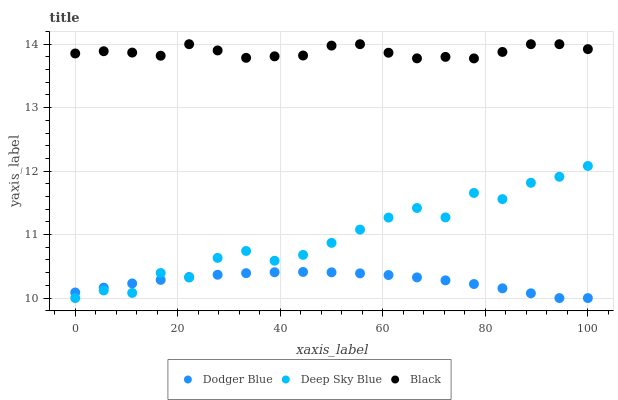Does Dodger Blue have the minimum area under the curve?
Answer yes or no. Yes. Does Black have the maximum area under the curve?
Answer yes or no. Yes. Does Deep Sky Blue have the minimum area under the curve?
Answer yes or no. No. Does Deep Sky Blue have the maximum area under the curve?
Answer yes or no. No. Is Dodger Blue the smoothest?
Answer yes or no. Yes. Is Deep Sky Blue the roughest?
Answer yes or no. Yes. Is Deep Sky Blue the smoothest?
Answer yes or no. No. Is Dodger Blue the roughest?
Answer yes or no. No. Does Dodger Blue have the lowest value?
Answer yes or no. Yes. Does Black have the highest value?
Answer yes or no. Yes. Does Deep Sky Blue have the highest value?
Answer yes or no. No. Is Dodger Blue less than Black?
Answer yes or no. Yes. Is Black greater than Dodger Blue?
Answer yes or no. Yes. Does Deep Sky Blue intersect Dodger Blue?
Answer yes or no. Yes. Is Deep Sky Blue less than Dodger Blue?
Answer yes or no. No. Is Deep Sky Blue greater than Dodger Blue?
Answer yes or no. No. Does Dodger Blue intersect Black?
Answer yes or no. No. 